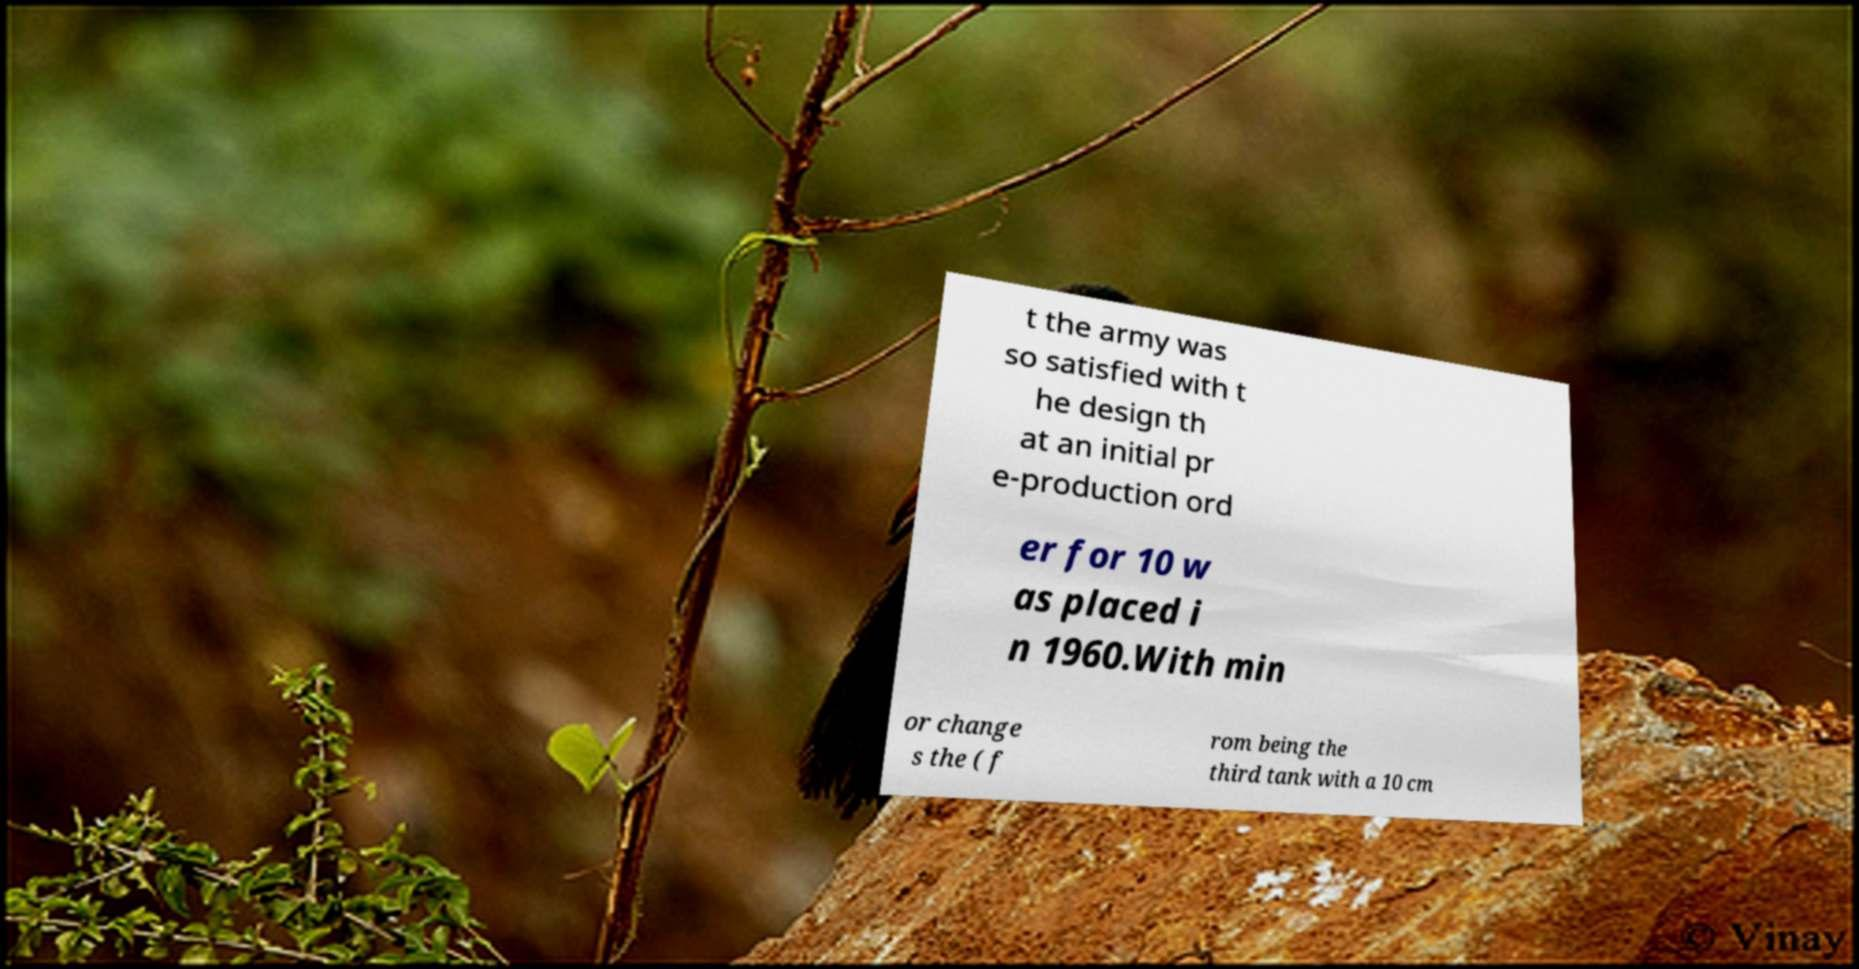There's text embedded in this image that I need extracted. Can you transcribe it verbatim? t the army was so satisfied with t he design th at an initial pr e-production ord er for 10 w as placed i n 1960.With min or change s the ( f rom being the third tank with a 10 cm 